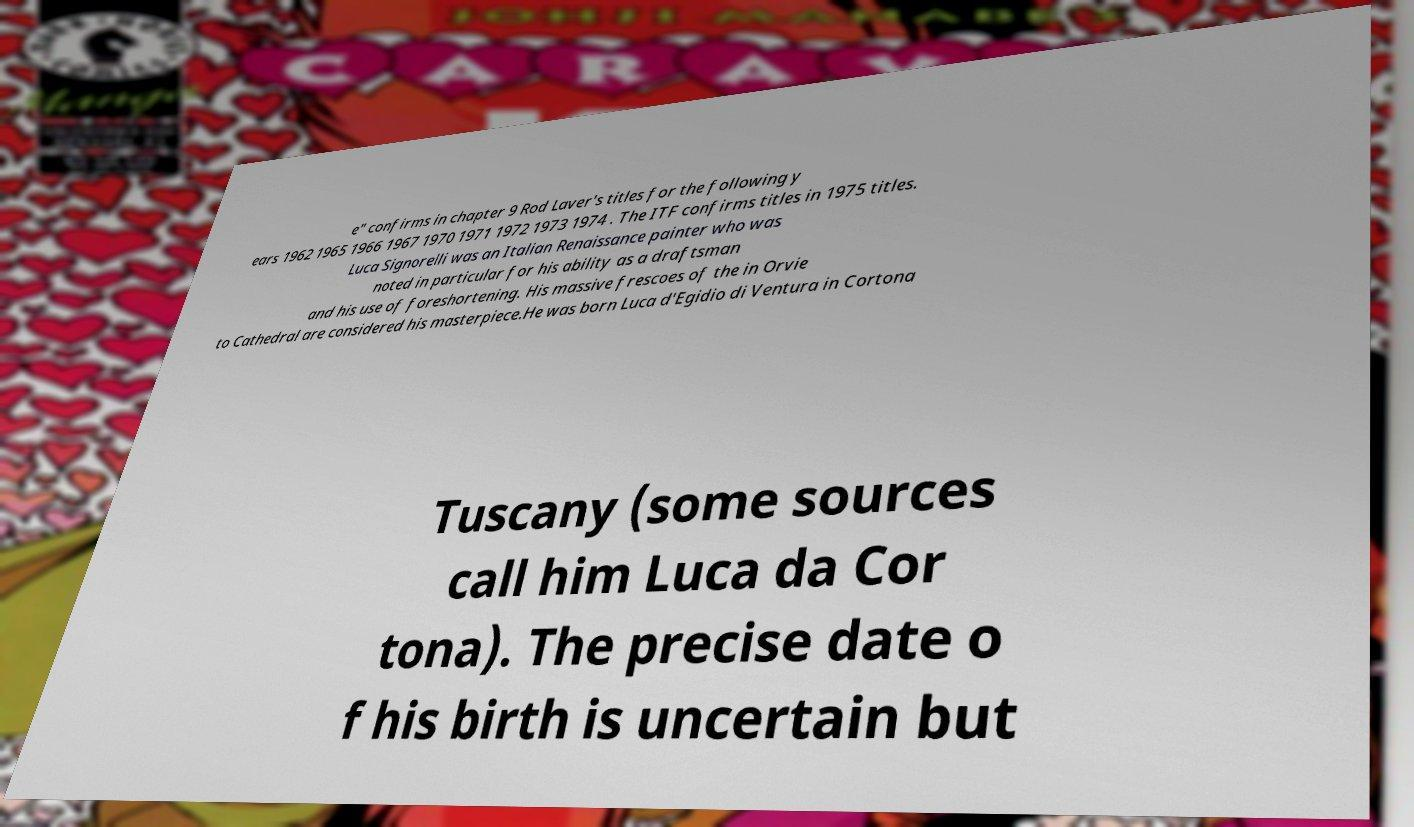What messages or text are displayed in this image? I need them in a readable, typed format. e" confirms in chapter 9 Rod Laver's titles for the following y ears 1962 1965 1966 1967 1970 1971 1972 1973 1974 . The ITF confirms titles in 1975 titles. Luca Signorelli was an Italian Renaissance painter who was noted in particular for his ability as a draftsman and his use of foreshortening. His massive frescoes of the in Orvie to Cathedral are considered his masterpiece.He was born Luca d'Egidio di Ventura in Cortona Tuscany (some sources call him Luca da Cor tona). The precise date o f his birth is uncertain but 